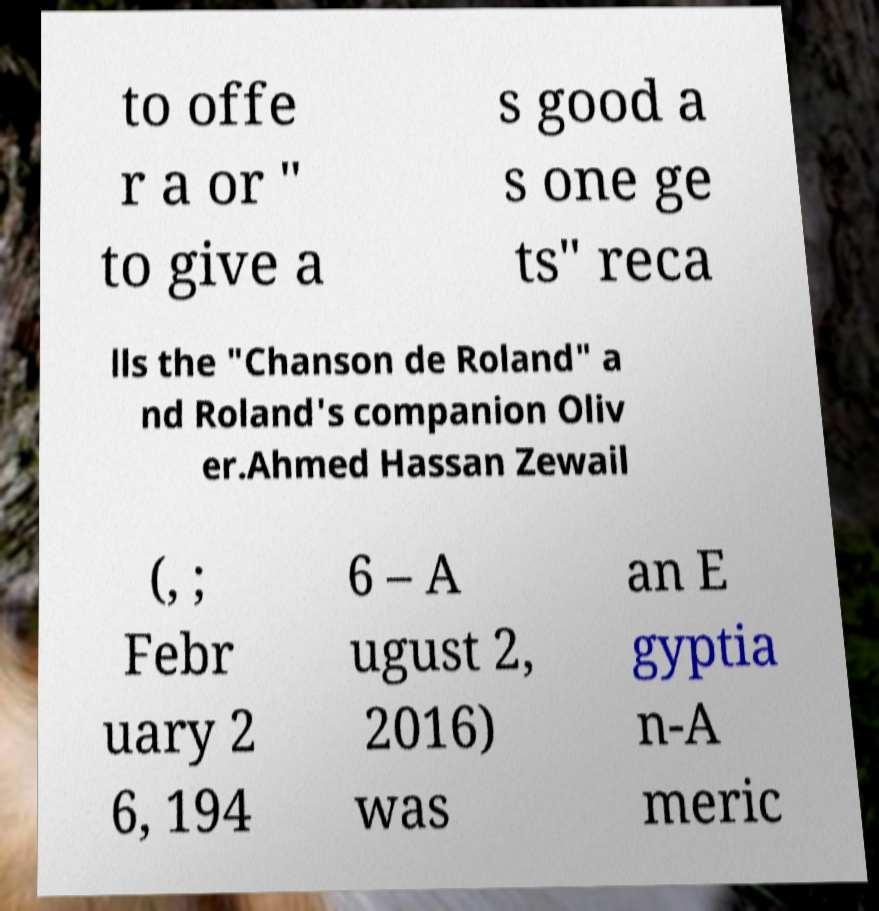For documentation purposes, I need the text within this image transcribed. Could you provide that? to offe r a or " to give a s good a s one ge ts" reca lls the "Chanson de Roland" a nd Roland's companion Oliv er.Ahmed Hassan Zewail (, ; Febr uary 2 6, 194 6 – A ugust 2, 2016) was an E gyptia n-A meric 